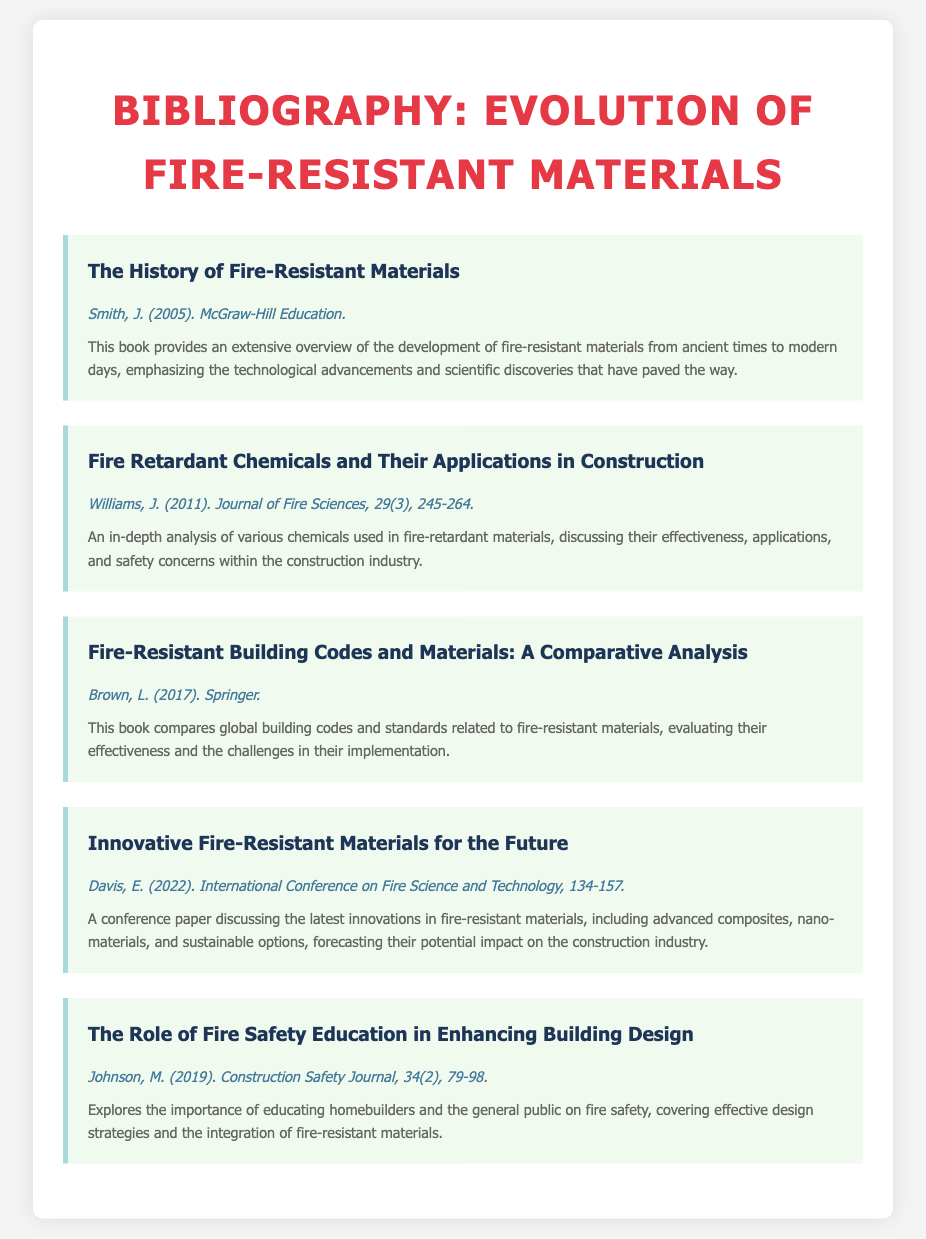What is the title of the first entry? The first entry is titled "The History of Fire-Resistant Materials".
Answer: The History of Fire-Resistant Materials Who is the author of the conference paper? The conference paper is authored by E. Davis.
Answer: E. Davis What year was "Fire Retardant Chemicals and Their Applications in Construction" published? This entry was published in the year 2011.
Answer: 2011 How many entries are listed in the bibliography? There are a total of five entries in the bibliography.
Answer: 5 What is the central theme of Johnson's article? The article focuses on fire safety education and its importance in building design.
Answer: Fire safety education What publisher released the book by L. Brown? The book by L. Brown was published by Springer.
Answer: Springer What type of document is this bibliography? This document is a bibliography focused on fire-resistant materials.
Answer: Bibliography In which journal was the article by J. Williams published? The article by J. Williams was published in the Journal of Fire Sciences.
Answer: Journal of Fire Sciences 